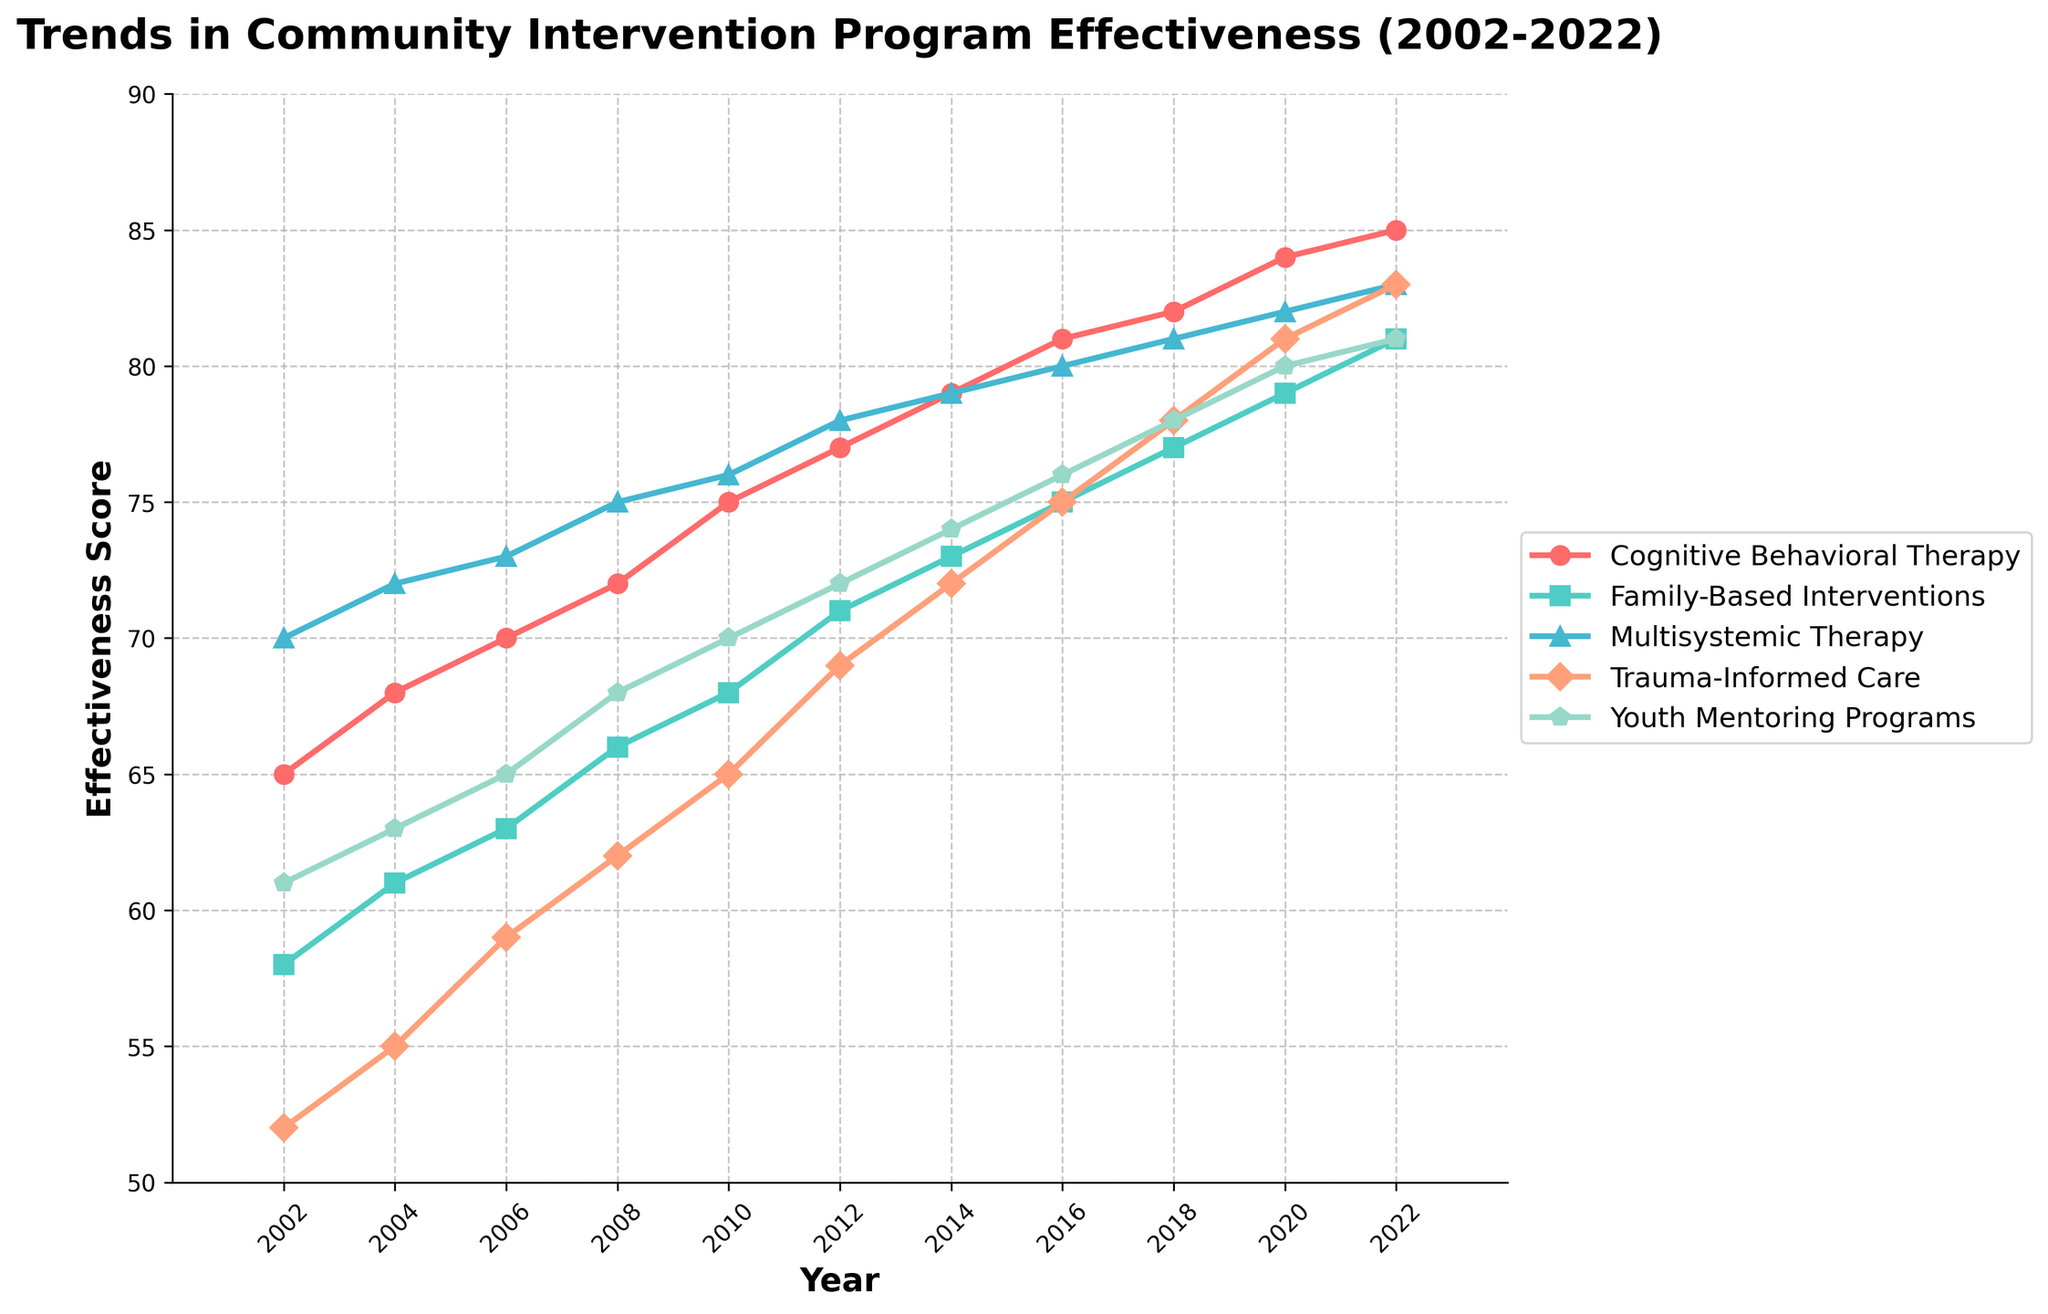What's the effectiveness score of Trauma-Informed Care in 2012? Identify the curve for Trauma-Informed Care and find the y-value corresponding to the year 2012.
Answer: 69 Between 2002 and 2022, which intervention showed the highest increase in effectiveness score? Calculate the difference in effectiveness score for each intervention type between 2002 and 2022, and compare the values.
Answer: Cognitive Behavioral Therapy What is the average effectiveness score of Family-Based Interventions across all years? Sum the effectiveness scores of Family-Based Interventions for all years and divide by the number of years. (58+61+63+66+68+71+73+75+77+79+81)/11 = 692/11.
Answer: 62.91 Which intervention had the highest effectiveness score in 2018? Identify the y-values for all intervention lines for the year 2018 and pick the highest value.
Answer: Cognitive Behavioral Therapy Compare the effectiveness scores of Youth Mentoring Programs and Multisystemic Therapy in 2020. Which was higher and by how much? Find the y-values for Youth Mentoring Programs (80) and Multisystemic Therapy (82) in 2020, and calculate the difference.
Answer: Multisystemic Therapy by 2 How much did the effectiveness score of Cognitive Behavioral Therapy increase from 2002 to 2022? Subtract the effectiveness score of Cognitive Behavioral Therapy in 2002 (65) from the score in 2022 (85).
Answer: 20 Which intervention had the smallest growth in effectiveness score over the 20-year period? Calculate the differences in effectiveness scores between 2002 and 2022 for all interventions and identify the smallest difference.
Answer: Youth Mentoring Programs In which year did Family-Based Interventions first surpass an effectiveness score of 70? Trace the Family-Based Interventions curve and find the first year where its y-value exceeds 70.
Answer: 2012 Of the five intervention types, which had the most consistent (least variable) effectiveness score trend over the years? Observe the smoothness and steepness of each curve to determine which one had the least variability.
Answer: Trauma-Informed Care 